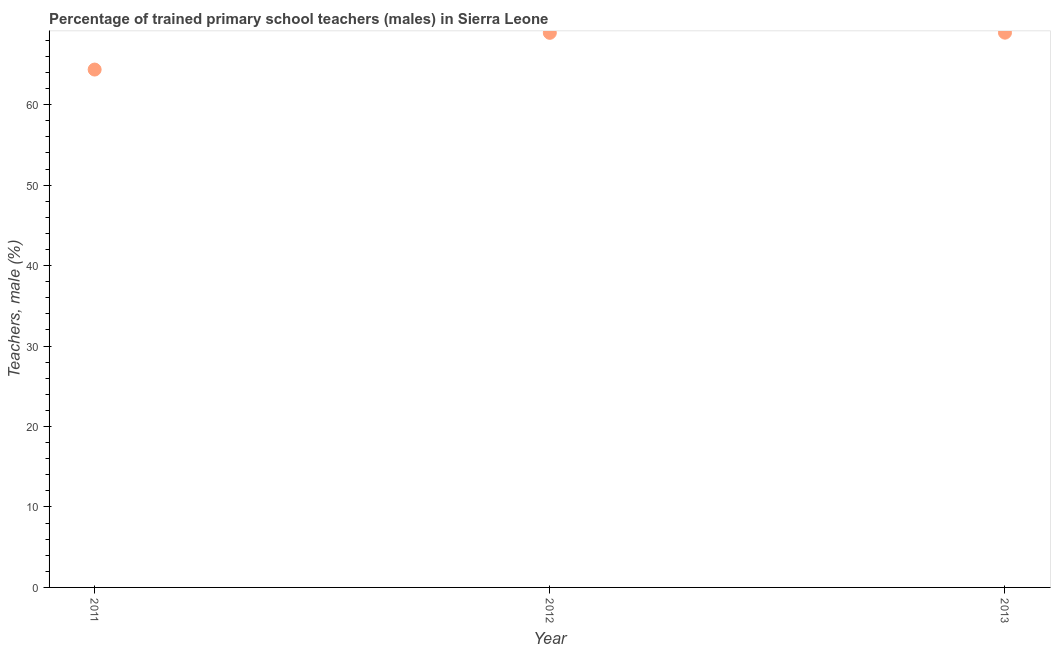What is the percentage of trained male teachers in 2011?
Your answer should be compact. 64.37. Across all years, what is the maximum percentage of trained male teachers?
Offer a very short reply. 68.96. Across all years, what is the minimum percentage of trained male teachers?
Your response must be concise. 64.37. What is the sum of the percentage of trained male teachers?
Provide a short and direct response. 202.27. What is the difference between the percentage of trained male teachers in 2011 and 2012?
Offer a terse response. -4.56. What is the average percentage of trained male teachers per year?
Ensure brevity in your answer.  67.42. What is the median percentage of trained male teachers?
Make the answer very short. 68.94. What is the ratio of the percentage of trained male teachers in 2011 to that in 2012?
Offer a terse response. 0.93. What is the difference between the highest and the second highest percentage of trained male teachers?
Provide a short and direct response. 0.02. Is the sum of the percentage of trained male teachers in 2012 and 2013 greater than the maximum percentage of trained male teachers across all years?
Your answer should be compact. Yes. What is the difference between the highest and the lowest percentage of trained male teachers?
Provide a short and direct response. 4.58. In how many years, is the percentage of trained male teachers greater than the average percentage of trained male teachers taken over all years?
Your answer should be compact. 2. What is the difference between two consecutive major ticks on the Y-axis?
Your answer should be very brief. 10. Does the graph contain grids?
Offer a very short reply. No. What is the title of the graph?
Ensure brevity in your answer.  Percentage of trained primary school teachers (males) in Sierra Leone. What is the label or title of the Y-axis?
Your response must be concise. Teachers, male (%). What is the Teachers, male (%) in 2011?
Your answer should be very brief. 64.37. What is the Teachers, male (%) in 2012?
Offer a very short reply. 68.94. What is the Teachers, male (%) in 2013?
Give a very brief answer. 68.96. What is the difference between the Teachers, male (%) in 2011 and 2012?
Your answer should be very brief. -4.56. What is the difference between the Teachers, male (%) in 2011 and 2013?
Your response must be concise. -4.58. What is the difference between the Teachers, male (%) in 2012 and 2013?
Your answer should be very brief. -0.02. What is the ratio of the Teachers, male (%) in 2011 to that in 2012?
Provide a succinct answer. 0.93. What is the ratio of the Teachers, male (%) in 2011 to that in 2013?
Your response must be concise. 0.93. What is the ratio of the Teachers, male (%) in 2012 to that in 2013?
Ensure brevity in your answer.  1. 